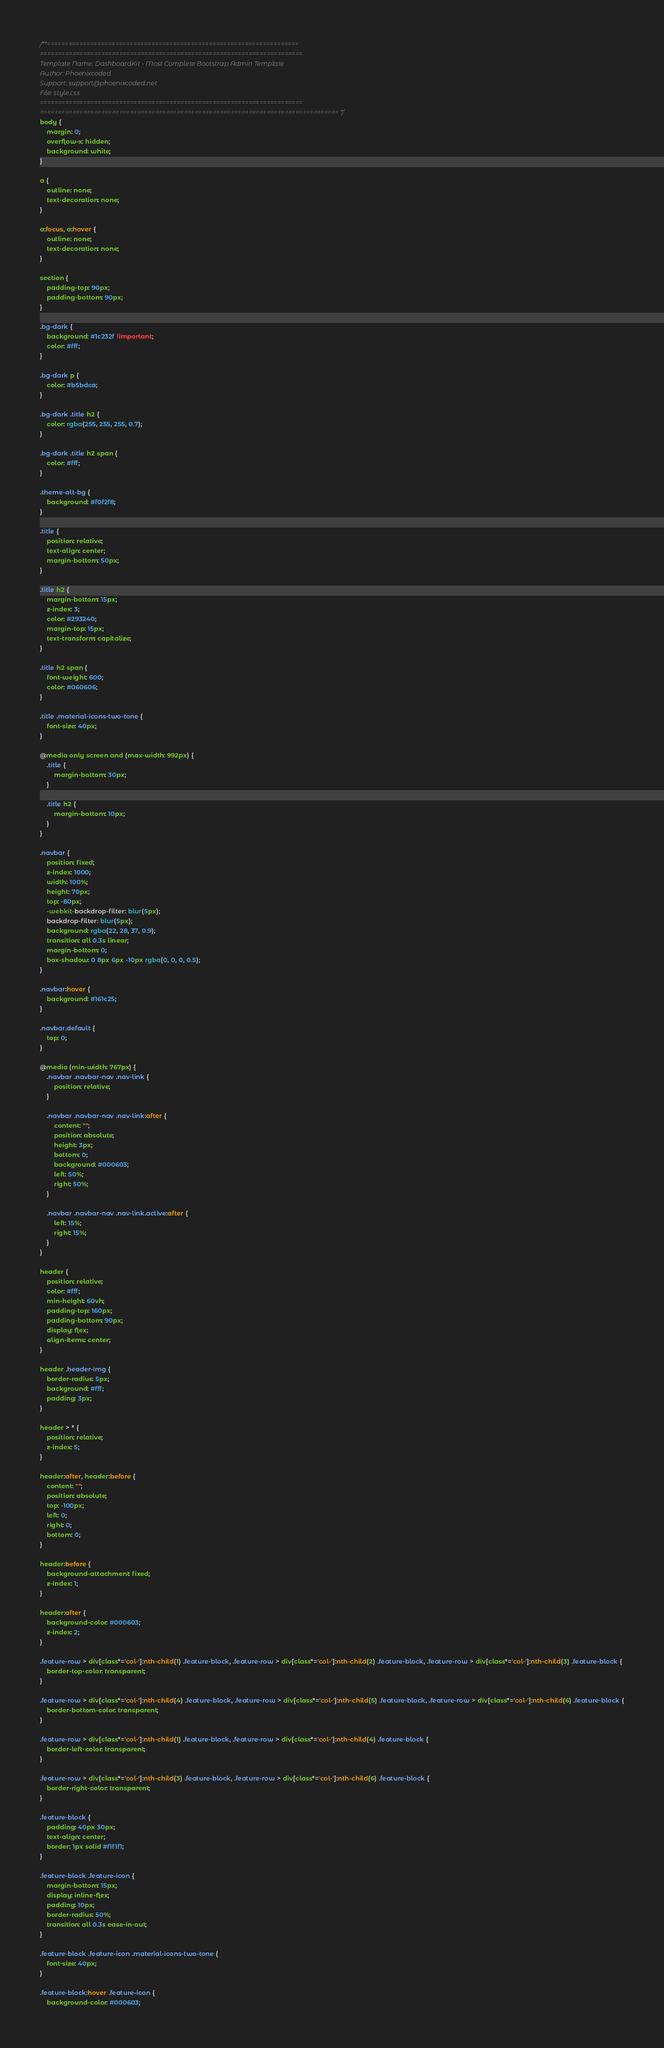<code> <loc_0><loc_0><loc_500><loc_500><_CSS_>/**======================================================================
=========================================================================
Template Name: DashboardKit - Most Complete Bootstrap Admin Template
Author: Phoenixcoded
Support: support@phoenixcoded.net
File: style.css
=========================================================================
=================================================================================== */
body {
    margin: 0;
    overflow-x: hidden;
    background: white;
}

a {
    outline: none;
    text-decoration: none;
}

a:focus, a:hover {
    outline: none;
    text-decoration: none;
}

section {
    padding-top: 90px;
    padding-bottom: 90px;
}

.bg-dark {
    background: #1c232f !important;
    color: #fff;
}

.bg-dark p {
    color: #b5bdca;
}

.bg-dark .title h2 {
    color: rgba(255, 255, 255, 0.7);
}

.bg-dark .title h2 span {
    color: #fff;
}

.theme-alt-bg {
    background: #f0f2f8;
}

.title {
    position: relative;
    text-align: center;
    margin-bottom: 50px;
}

.title h2 {
    margin-bottom: 15px;
    z-index: 3;
    color: #293240;
    margin-top: 15px;
    text-transform: capitalize;
}

.title h2 span {
    font-weight: 600;
    color: #060606;
}

.title .material-icons-two-tone {
    font-size: 40px;
}

@media only screen and (max-width: 992px) {
    .title {
        margin-bottom: 30px;
    }

    .title h2 {
        margin-bottom: 10px;
    }
}

.navbar {
    position: fixed;
    z-index: 1000;
    width: 100%;
    height: 70px;
    top: -80px;
    -webkit-backdrop-filter: blur(5px);
    backdrop-filter: blur(5px);
    background: rgba(22, 28, 37, 0.9);
    transition: all 0.3s linear;
    margin-bottom: 0;
    box-shadow: 0 8px 6px -10px rgba(0, 0, 0, 0.5);
}

.navbar:hover {
    background: #161c25;
}

.navbar.default {
    top: 0;
}

@media (min-width: 767px) {
    .navbar .navbar-nav .nav-link {
        position: relative;
    }

    .navbar .navbar-nav .nav-link:after {
        content: "";
        position: absolute;
        height: 3px;
        bottom: 0;
        background: #000603;
        left: 50%;
        right: 50%;
    }

    .navbar .navbar-nav .nav-link.active:after {
        left: 15%;
        right: 15%;
    }
}

header {
    position: relative;
    color: #fff;
    min-height: 60vh;
    padding-top: 160px;
    padding-bottom: 90px;
    display: flex;
    align-items: center;
}

header .header-img {
    border-radius: 5px;
    background: #fff;
    padding: 3px;
}

header > * {
    position: relative;
    z-index: 5;
}

header:after, header:before {
    content: "";
    position: absolute;
    top: -100px;
    left: 0;
    right: 0;
    bottom: 0;
}

header:before {
    background-attachment: fixed;
    z-index: 1;
}

header:after {
    background-color: #000603;
    z-index: 2;
}

.feature-row > div[class*='col-']:nth-child(1) .feature-block, .feature-row > div[class*='col-']:nth-child(2) .feature-block, .feature-row > div[class*='col-']:nth-child(3) .feature-block {
    border-top-color: transparent;
}

.feature-row > div[class*='col-']:nth-child(4) .feature-block, .feature-row > div[class*='col-']:nth-child(5) .feature-block, .feature-row > div[class*='col-']:nth-child(6) .feature-block {
    border-bottom-color: transparent;
}

.feature-row > div[class*='col-']:nth-child(1) .feature-block, .feature-row > div[class*='col-']:nth-child(4) .feature-block {
    border-left-color: transparent;
}

.feature-row > div[class*='col-']:nth-child(3) .feature-block, .feature-row > div[class*='col-']:nth-child(6) .feature-block {
    border-right-color: transparent;
}

.feature-block {
    padding: 40px 30px;
    text-align: center;
    border: 1px solid #f1f1f1;
}

.feature-block .feature-icon {
    margin-bottom: 15px;
    display: inline-flex;
    padding: 10px;
    border-radius: 50%;
    transition: all 0.3s ease-in-out;
}

.feature-block .feature-icon .material-icons-two-tone {
    font-size: 40px;
}

.feature-block:hover .feature-icon {
    background-color: #000603;</code> 